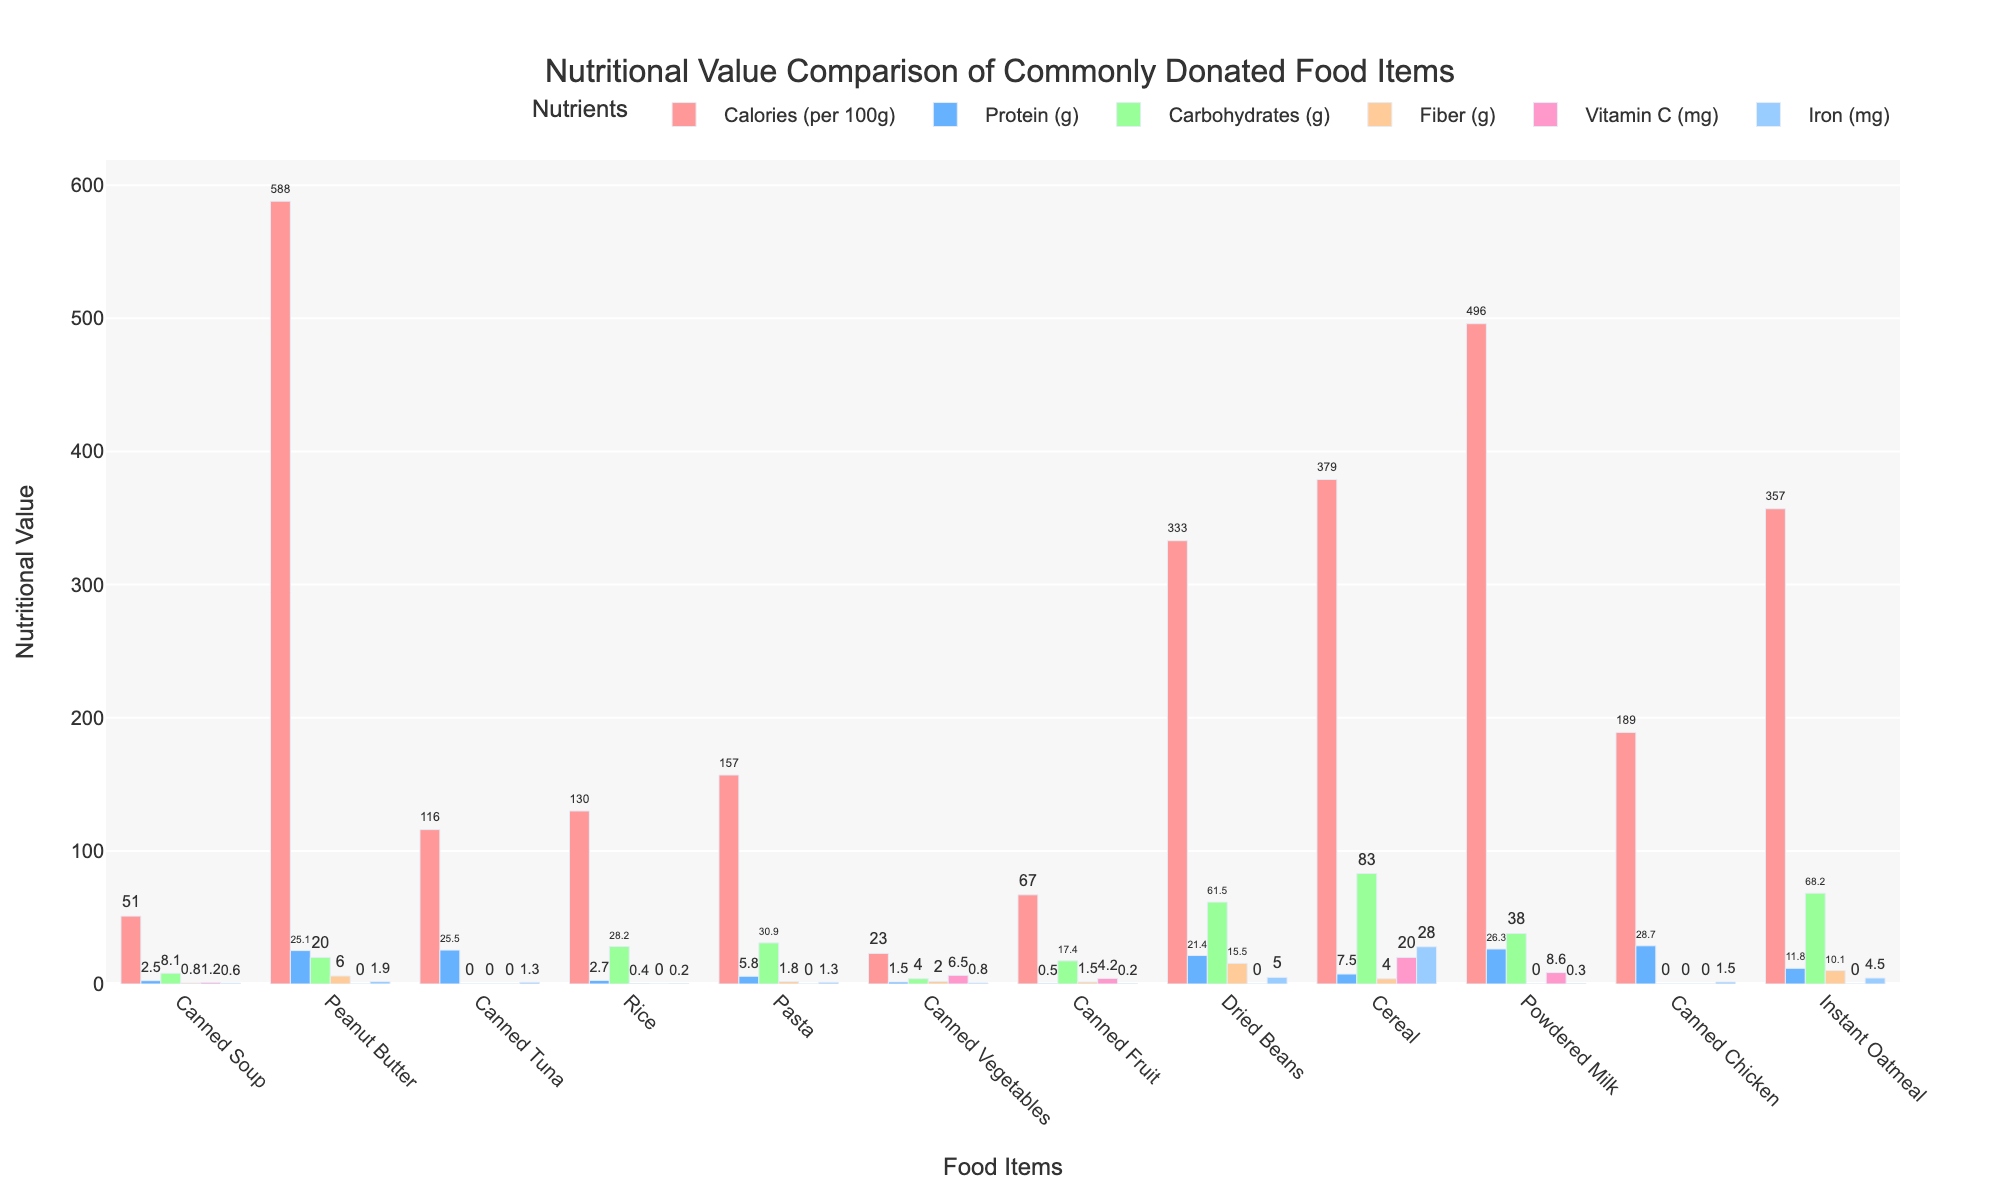Which food item has the highest calorie content per 100g? By observing the height of the bars representing calories, we can see that Peanut Butter has the tallest bar, indicating it has the highest calorie content per 100g.
Answer: Peanut Butter Which food items contain Vitamin C? By observing the bars for Vitamin C, we see that Canned Vegetables, Canned Fruit, Powdered Milk, and Cereal all have values greater than zero, indicating they contain Vitamin C.
Answer: Canned Vegetables, Canned Fruit, Powdered Milk, Cereal Which food item is the best source of protein? By observing the bars representing protein content, Canned Chicken has the tallest bar, indicating it has the highest protein content.
Answer: Canned Chicken Compare the carbohydrate content between rice and pasta, which one has more carbohydrates? By comparing the height of the bars representing carbohydrates for both food items, Pasta has a taller bar compared to Rice, indicating Pasta has more carbohydrates.
Answer: Pasta What is the difference in fiber content between dried beans and instant oatmeal? By observing the heights of the bars representing fiber content, Dried Beans have a height of 15.5 and Instant Oatmeal 10.1. The difference is \( 15.5 - 10.1 = 5.4 \).
Answer: 5.4 Which food item has the highest iron content and how much is it? By observing the bars representing iron content, Cereal has the tallest bar, indicating the highest iron content, which is 28.0 mg.
Answer: Cereal, 28.0 mg Rank the food items based on their fiber content from highest to lowest. By examining the bars representing fiber, from highest to lowest: Dried Beans (15.5), Instant Oatmeal (10.1), Cereal (4.0), Canned Vegetables (2.0), Pasta (1.8), Canned Fruit (1.5), Canned Soup (0.8), Rice (0.4), and the rest (0.0).
Answer: Dried Beans, Instant Oatmeal, Cereal, Canned Vegetables, Pasta, Canned Fruit, Canned Soup, Rice, others (0.0) Which food item has zero carbohydrates? By observing which food items have a bar height of zero for carbohydrates, Canned Tuna and Canned Chicken show zero values.
Answer: Canned Tuna and Canned Chicken What is the combined protein content of canned tuna and powdered milk? By adding the protein values of Canned Tuna (25.5) and Powdered Milk (26.3), we get \( 25.5 + 26.3 = 51.8 \).
Answer: 51.8 Is the fiber content of dried beans greater or less than the sum of fiber content in canned soup and canned vegetables? The fiber content for Dried Beans is 15.5, while the combined fiber content for Canned Soup (0.8) and Canned Vegetables (2.0) is \( 0.8 + 2.0 = 2.8 \). 15.5 is greater than 2.8.
Answer: Greater 